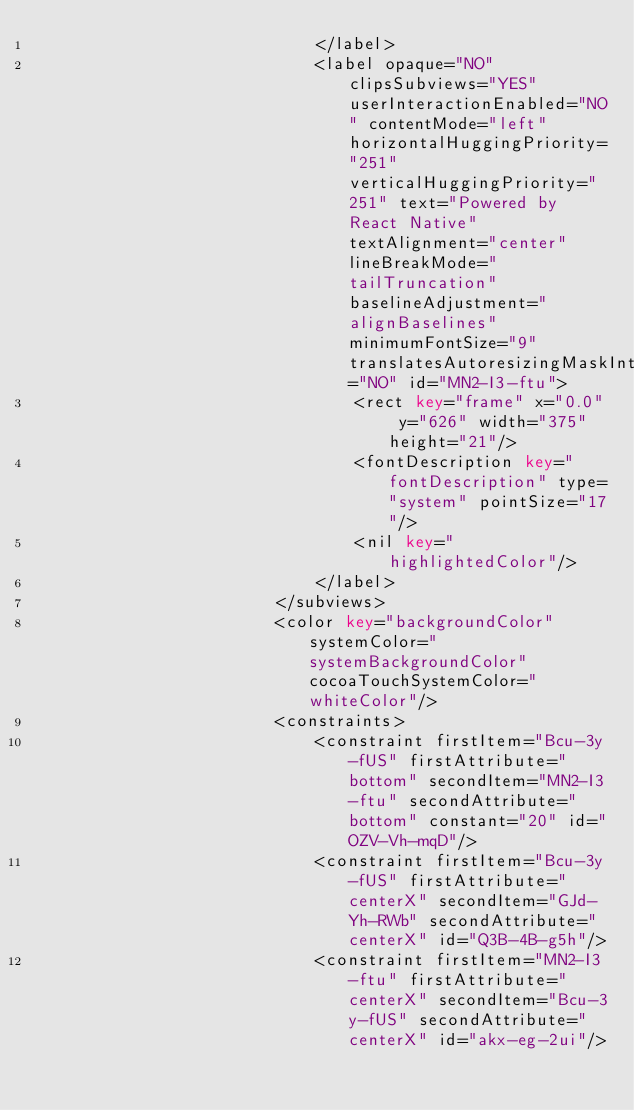Convert code to text. <code><loc_0><loc_0><loc_500><loc_500><_XML_>                            </label>
                            <label opaque="NO" clipsSubviews="YES" userInteractionEnabled="NO" contentMode="left" horizontalHuggingPriority="251" verticalHuggingPriority="251" text="Powered by React Native" textAlignment="center" lineBreakMode="tailTruncation" baselineAdjustment="alignBaselines" minimumFontSize="9" translatesAutoresizingMaskIntoConstraints="NO" id="MN2-I3-ftu">
                                <rect key="frame" x="0.0" y="626" width="375" height="21"/>
                                <fontDescription key="fontDescription" type="system" pointSize="17"/>
                                <nil key="highlightedColor"/>
                            </label>
                        </subviews>
                        <color key="backgroundColor" systemColor="systemBackgroundColor" cocoaTouchSystemColor="whiteColor"/>
                        <constraints>
                            <constraint firstItem="Bcu-3y-fUS" firstAttribute="bottom" secondItem="MN2-I3-ftu" secondAttribute="bottom" constant="20" id="OZV-Vh-mqD"/>
                            <constraint firstItem="Bcu-3y-fUS" firstAttribute="centerX" secondItem="GJd-Yh-RWb" secondAttribute="centerX" id="Q3B-4B-g5h"/>
                            <constraint firstItem="MN2-I3-ftu" firstAttribute="centerX" secondItem="Bcu-3y-fUS" secondAttribute="centerX" id="akx-eg-2ui"/></code> 